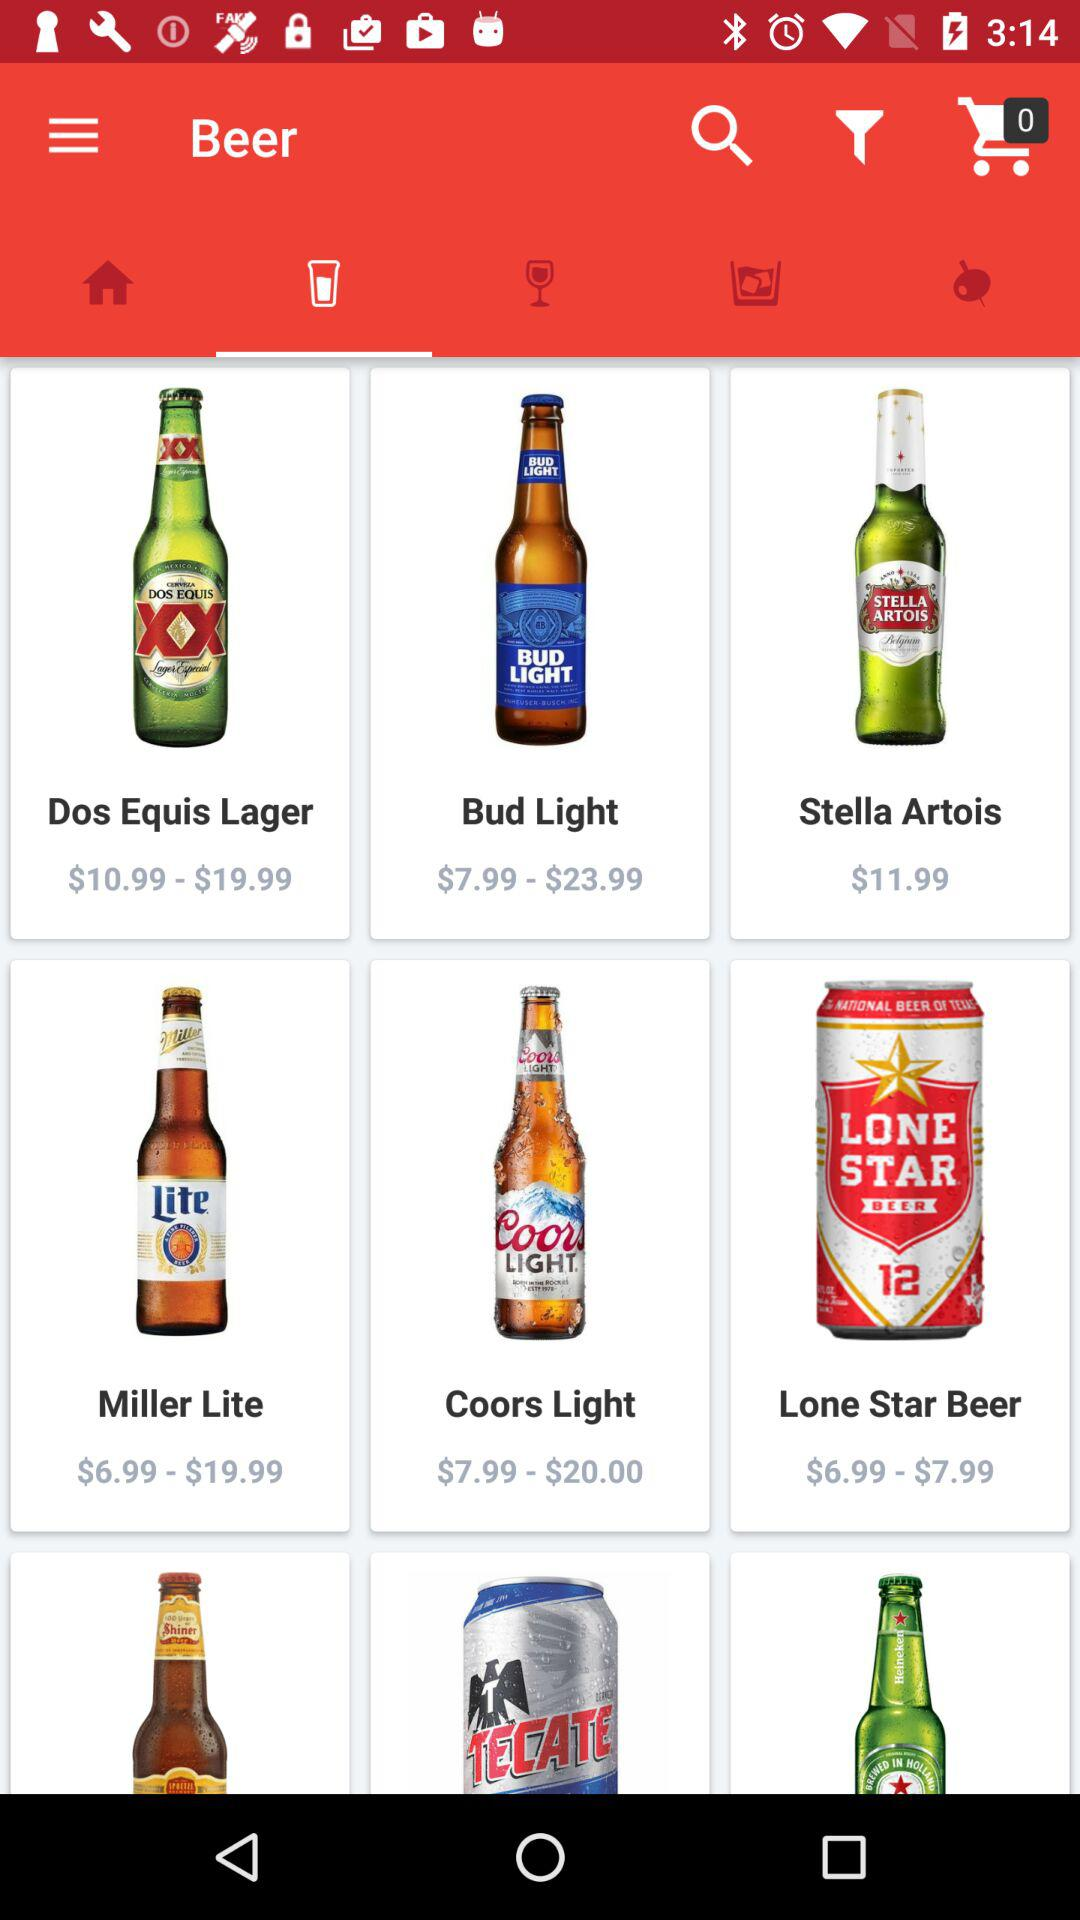How many items are in the shopping cart? There are 0 items in the shopping cart. 